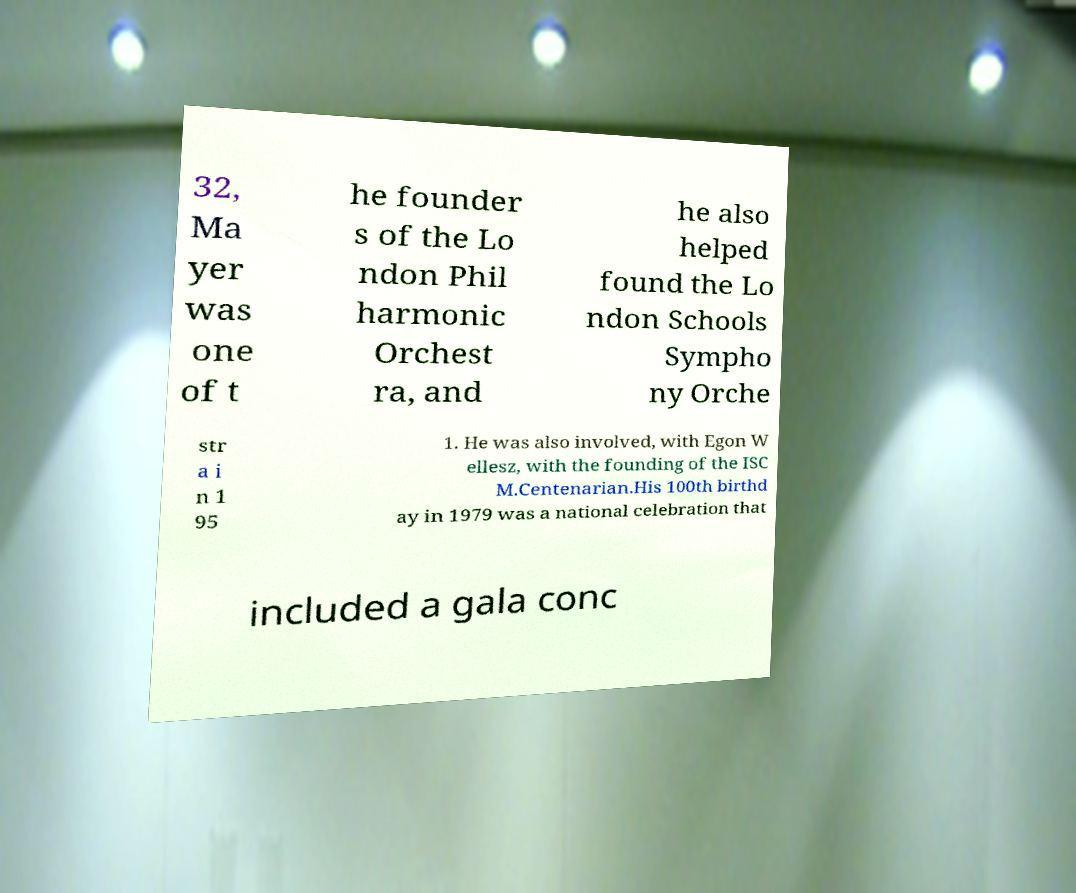Please read and relay the text visible in this image. What does it say? 32, Ma yer was one of t he founder s of the Lo ndon Phil harmonic Orchest ra, and he also helped found the Lo ndon Schools Sympho ny Orche str a i n 1 95 1. He was also involved, with Egon W ellesz, with the founding of the ISC M.Centenarian.His 100th birthd ay in 1979 was a national celebration that included a gala conc 